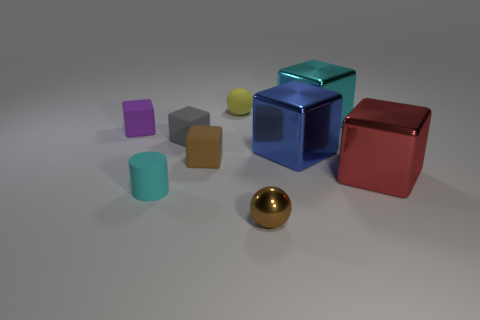There is a ball behind the purple cube; does it have the same size as the tiny brown shiny object?
Your response must be concise. Yes. What size is the ball that is in front of the tiny gray matte object?
Ensure brevity in your answer.  Small. Is there anything else that is the same material as the small gray cube?
Offer a terse response. Yes. What number of big blue cubes are there?
Offer a very short reply. 1. Is the color of the cylinder the same as the metal ball?
Make the answer very short. No. What is the color of the metallic thing that is left of the cyan shiny cube and behind the rubber cylinder?
Ensure brevity in your answer.  Blue. Are there any purple rubber blocks left of the brown cube?
Offer a very short reply. Yes. There is a small block that is left of the small rubber cylinder; what number of objects are in front of it?
Provide a succinct answer. 6. The yellow ball that is the same material as the cylinder is what size?
Give a very brief answer. Small. The brown rubber cube is what size?
Provide a short and direct response. Small. 